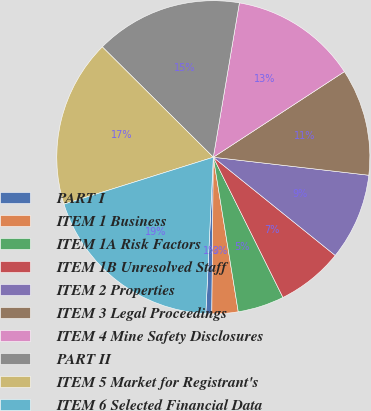Convert chart. <chart><loc_0><loc_0><loc_500><loc_500><pie_chart><fcel>PART I<fcel>ITEM 1 Business<fcel>ITEM 1A Risk Factors<fcel>ITEM 1B Unresolved Staff<fcel>ITEM 2 Properties<fcel>ITEM 3 Legal Proceedings<fcel>ITEM 4 Mine Safety Disclosures<fcel>PART II<fcel>ITEM 5 Market for Registrant's<fcel>ITEM 6 Selected Financial Data<nl><fcel>0.61%<fcel>2.7%<fcel>4.79%<fcel>6.87%<fcel>8.96%<fcel>11.04%<fcel>13.13%<fcel>15.21%<fcel>17.3%<fcel>19.39%<nl></chart> 